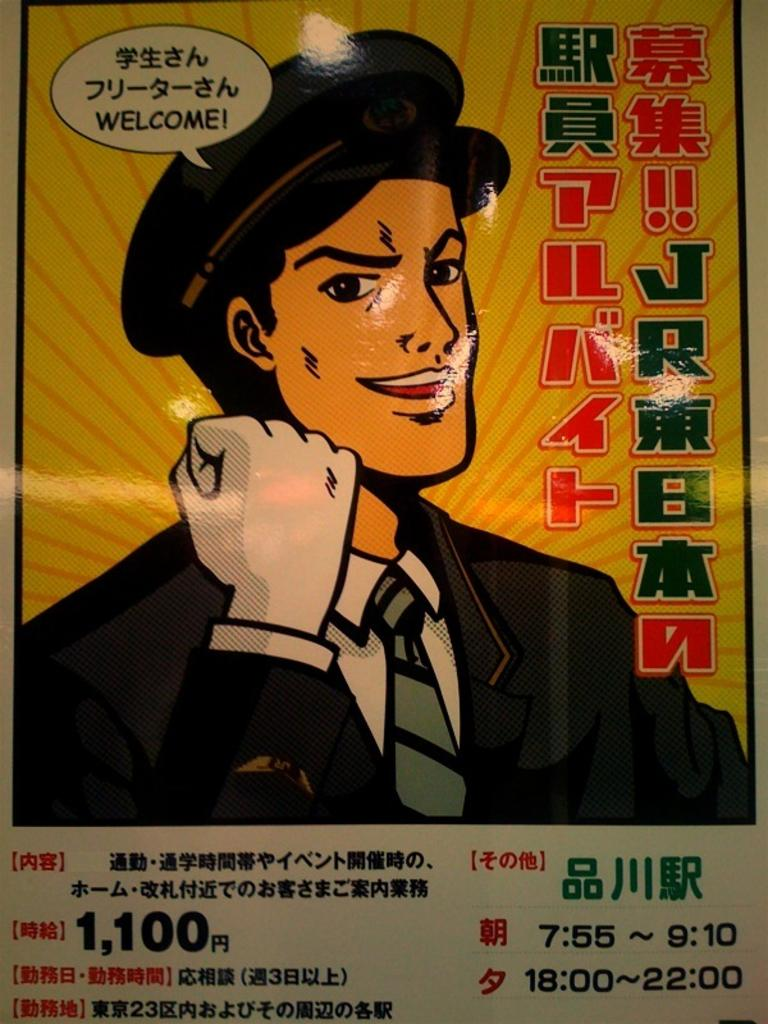What is depicted on the poster in the image? There is a poster in the image, and it features a man. What is the man wearing in the poster? The man is wearing a black jacket in the poster. What type of story is the man telling in the poster? There is no story being told in the poster; it simply features a man wearing a black jacket. Is the man swimming in the poster? There is no indication of swimming in the poster; the man is wearing a black jacket and standing still. 